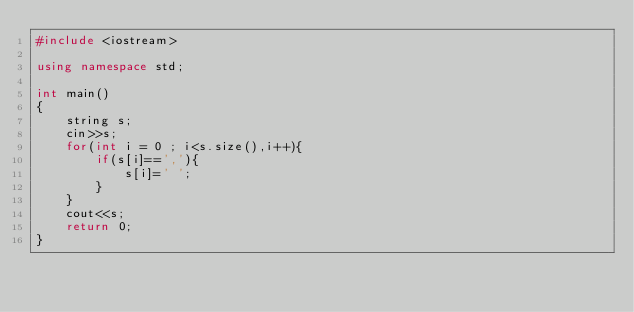<code> <loc_0><loc_0><loc_500><loc_500><_C++_>#include <iostream>

using namespace std;

int main()
{
    string s;
    cin>>s;
    for(int i = 0 ; i<s.size(),i++){
        if(s[i]==','){
            s[i]=' ';
        }
    }
    cout<<s;
    return 0;
}
</code> 